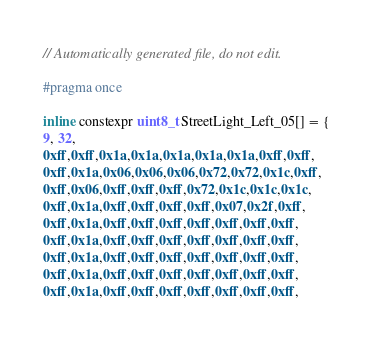<code> <loc_0><loc_0><loc_500><loc_500><_C_>// Automatically generated file, do not edit.

#pragma once

inline constexpr uint8_t StreetLight_Left_05[] = {
9, 32,
0xff,0xff,0x1a,0x1a,0x1a,0x1a,0x1a,0xff,0xff,
0xff,0x1a,0x06,0x06,0x06,0x72,0x72,0x1c,0xff,
0xff,0x06,0xff,0xff,0xff,0x72,0x1c,0x1c,0x1c,
0xff,0x1a,0xff,0xff,0xff,0xff,0x07,0x2f,0xff,
0xff,0x1a,0xff,0xff,0xff,0xff,0xff,0xff,0xff,
0xff,0x1a,0xff,0xff,0xff,0xff,0xff,0xff,0xff,
0xff,0x1a,0xff,0xff,0xff,0xff,0xff,0xff,0xff,
0xff,0x1a,0xff,0xff,0xff,0xff,0xff,0xff,0xff,
0xff,0x1a,0xff,0xff,0xff,0xff,0xff,0xff,0xff,</code> 